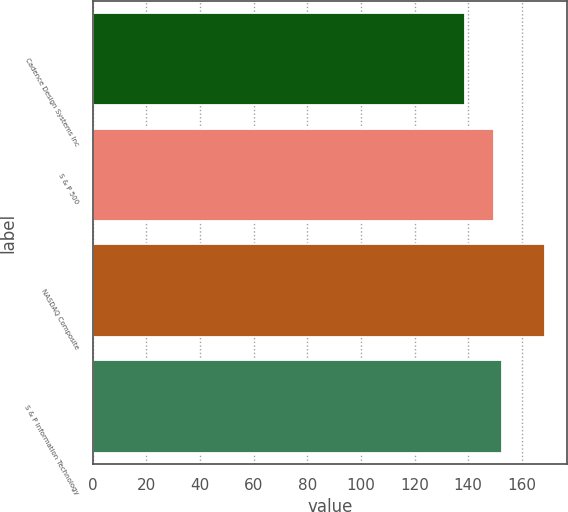<chart> <loc_0><loc_0><loc_500><loc_500><bar_chart><fcel>Cadence Design Systems Inc<fcel>S & P 500<fcel>NASDAQ Composite<fcel>S & P Information Technology<nl><fcel>138.92<fcel>149.7<fcel>168.6<fcel>152.67<nl></chart> 